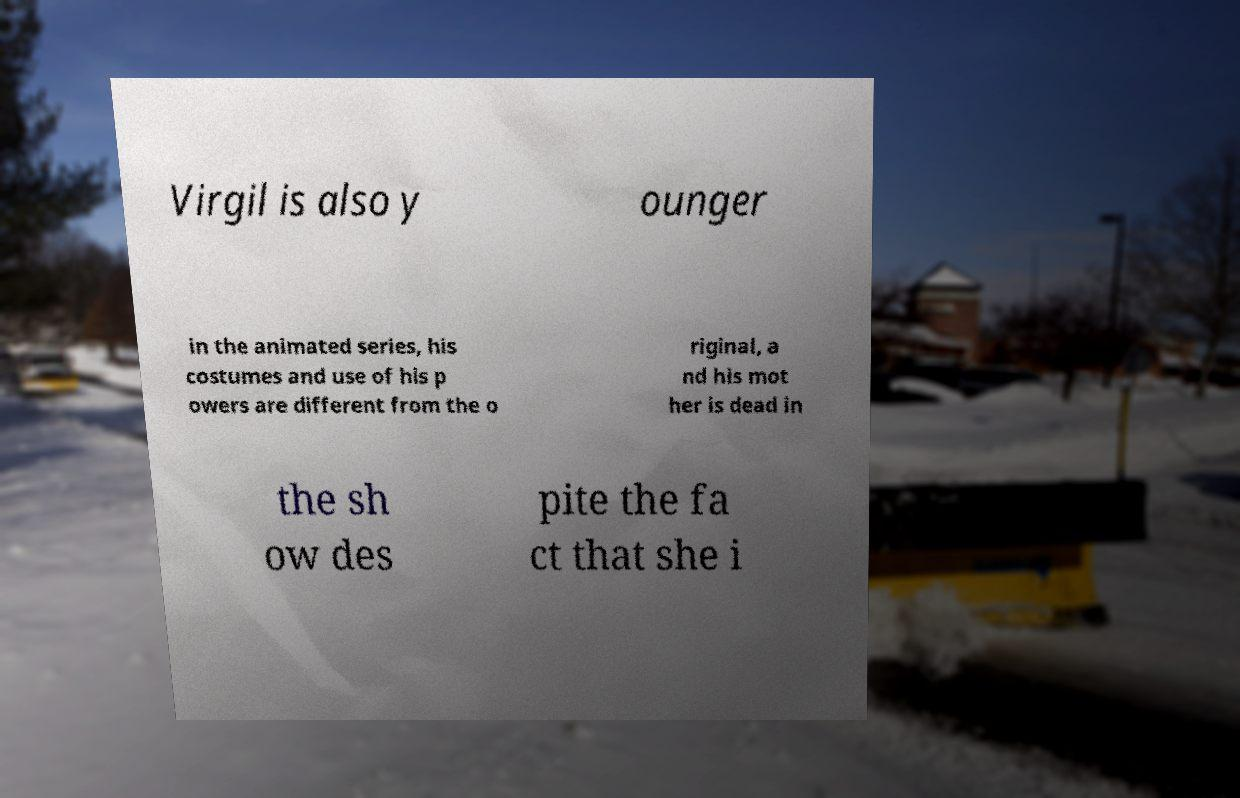Please read and relay the text visible in this image. What does it say? Virgil is also y ounger in the animated series, his costumes and use of his p owers are different from the o riginal, a nd his mot her is dead in the sh ow des pite the fa ct that she i 